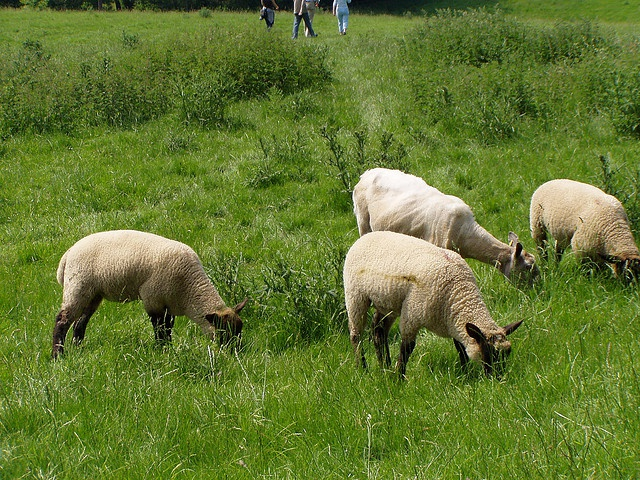Describe the objects in this image and their specific colors. I can see sheep in black, darkgreen, beige, and tan tones, sheep in black, darkgreen, tan, and beige tones, sheep in black, ivory, olive, gray, and tan tones, sheep in black, tan, and olive tones, and people in black, gray, and teal tones in this image. 